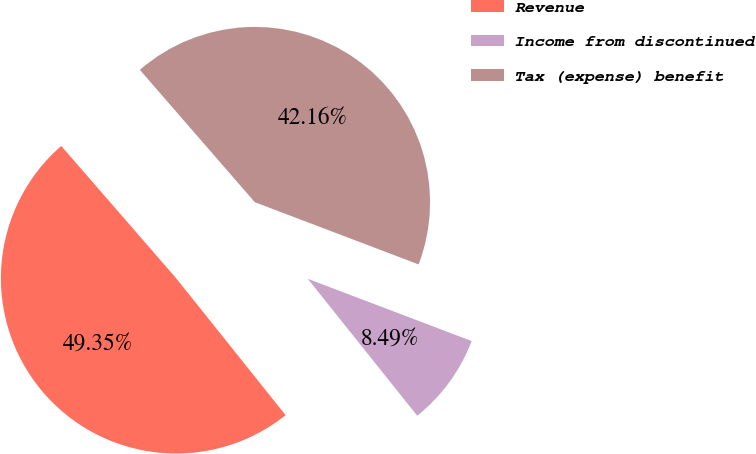<chart> <loc_0><loc_0><loc_500><loc_500><pie_chart><fcel>Revenue<fcel>Income from discontinued<fcel>Tax (expense) benefit<nl><fcel>49.35%<fcel>8.49%<fcel>42.16%<nl></chart> 